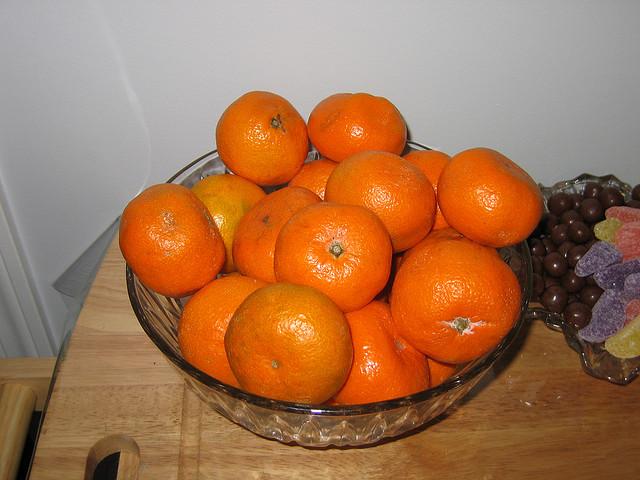Is there a tablecloth under the bowl of oranges?
Write a very short answer. No. Is everything in the bowls healthy for a human to eat?
Concise answer only. Yes. How many varieties of fruit are on the counter?
Give a very brief answer. 2. What is in the bowl?
Quick response, please. Oranges. How many oranges here?
Be succinct. 16. How many oranges are there?
Write a very short answer. 15. What is the bowl made of?
Answer briefly. Glass. Is the orange pictured a blood orange?
Concise answer only. No. How many oranges can you see?
Answer briefly. 15. What is in the bow that is brown color?
Write a very short answer. Chocolate. How can you tell the fruit were store bought?
Quick response, please. Can't. Which objects match?
Short answer required. Oranges. How many different types of fruit are in the bowl?
Keep it brief. 1. Of what is the bowl made?
Keep it brief. Glass. Have these fruits just been picked?
Keep it brief. No. Are these oranges for sale?
Give a very brief answer. No. How many oranges are seen?
Short answer required. 15. Are there more than one type of fruits?
Give a very brief answer. Yes. Is there a variety?
Give a very brief answer. No. 